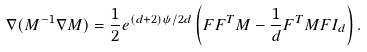Convert formula to latex. <formula><loc_0><loc_0><loc_500><loc_500>\nabla ( M ^ { - 1 } \nabla M ) = \frac { 1 } { 2 } e ^ { ( d + 2 ) \psi / 2 d } \left ( F F ^ { T } M - \frac { 1 } { d } F ^ { T } M F I _ { d } \right ) .</formula> 